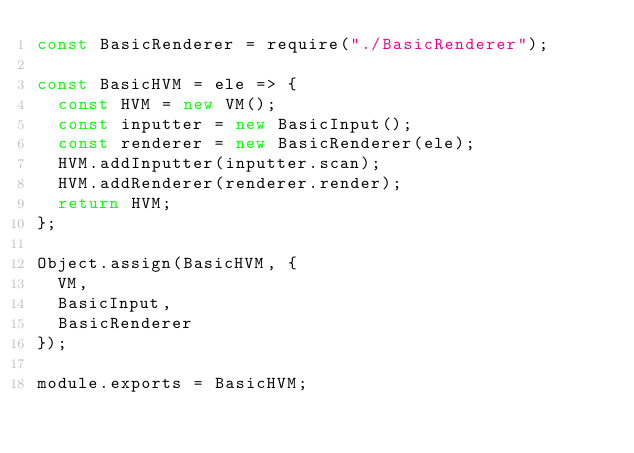Convert code to text. <code><loc_0><loc_0><loc_500><loc_500><_JavaScript_>const BasicRenderer = require("./BasicRenderer");

const BasicHVM = ele => {
  const HVM = new VM();
  const inputter = new BasicInput();
  const renderer = new BasicRenderer(ele);
  HVM.addInputter(inputter.scan);
  HVM.addRenderer(renderer.render);
  return HVM;
};

Object.assign(BasicHVM, {
  VM,
  BasicInput,
  BasicRenderer
});

module.exports = BasicHVM;
</code> 